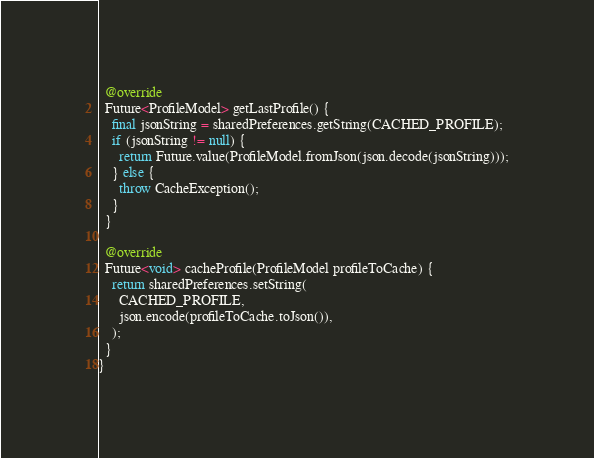Convert code to text. <code><loc_0><loc_0><loc_500><loc_500><_Dart_>
  @override
  Future<ProfileModel> getLastProfile() {
    final jsonString = sharedPreferences.getString(CACHED_PROFILE);
    if (jsonString != null) {
      return Future.value(ProfileModel.fromJson(json.decode(jsonString)));
    } else {
      throw CacheException();
    }
  }

  @override
  Future<void> cacheProfile(ProfileModel profileToCache) {
    return sharedPreferences.setString(
      CACHED_PROFILE,
      json.encode(profileToCache.toJson()),
    );
  }
}
</code> 